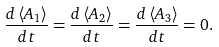<formula> <loc_0><loc_0><loc_500><loc_500>\frac { d \left \langle A _ { 1 } \right \rangle } { d t } = \frac { d \left \langle A _ { 2 } \right \rangle } { d t } = \frac { d \left \langle A _ { 3 } \right \rangle } { d t } = 0 .</formula> 